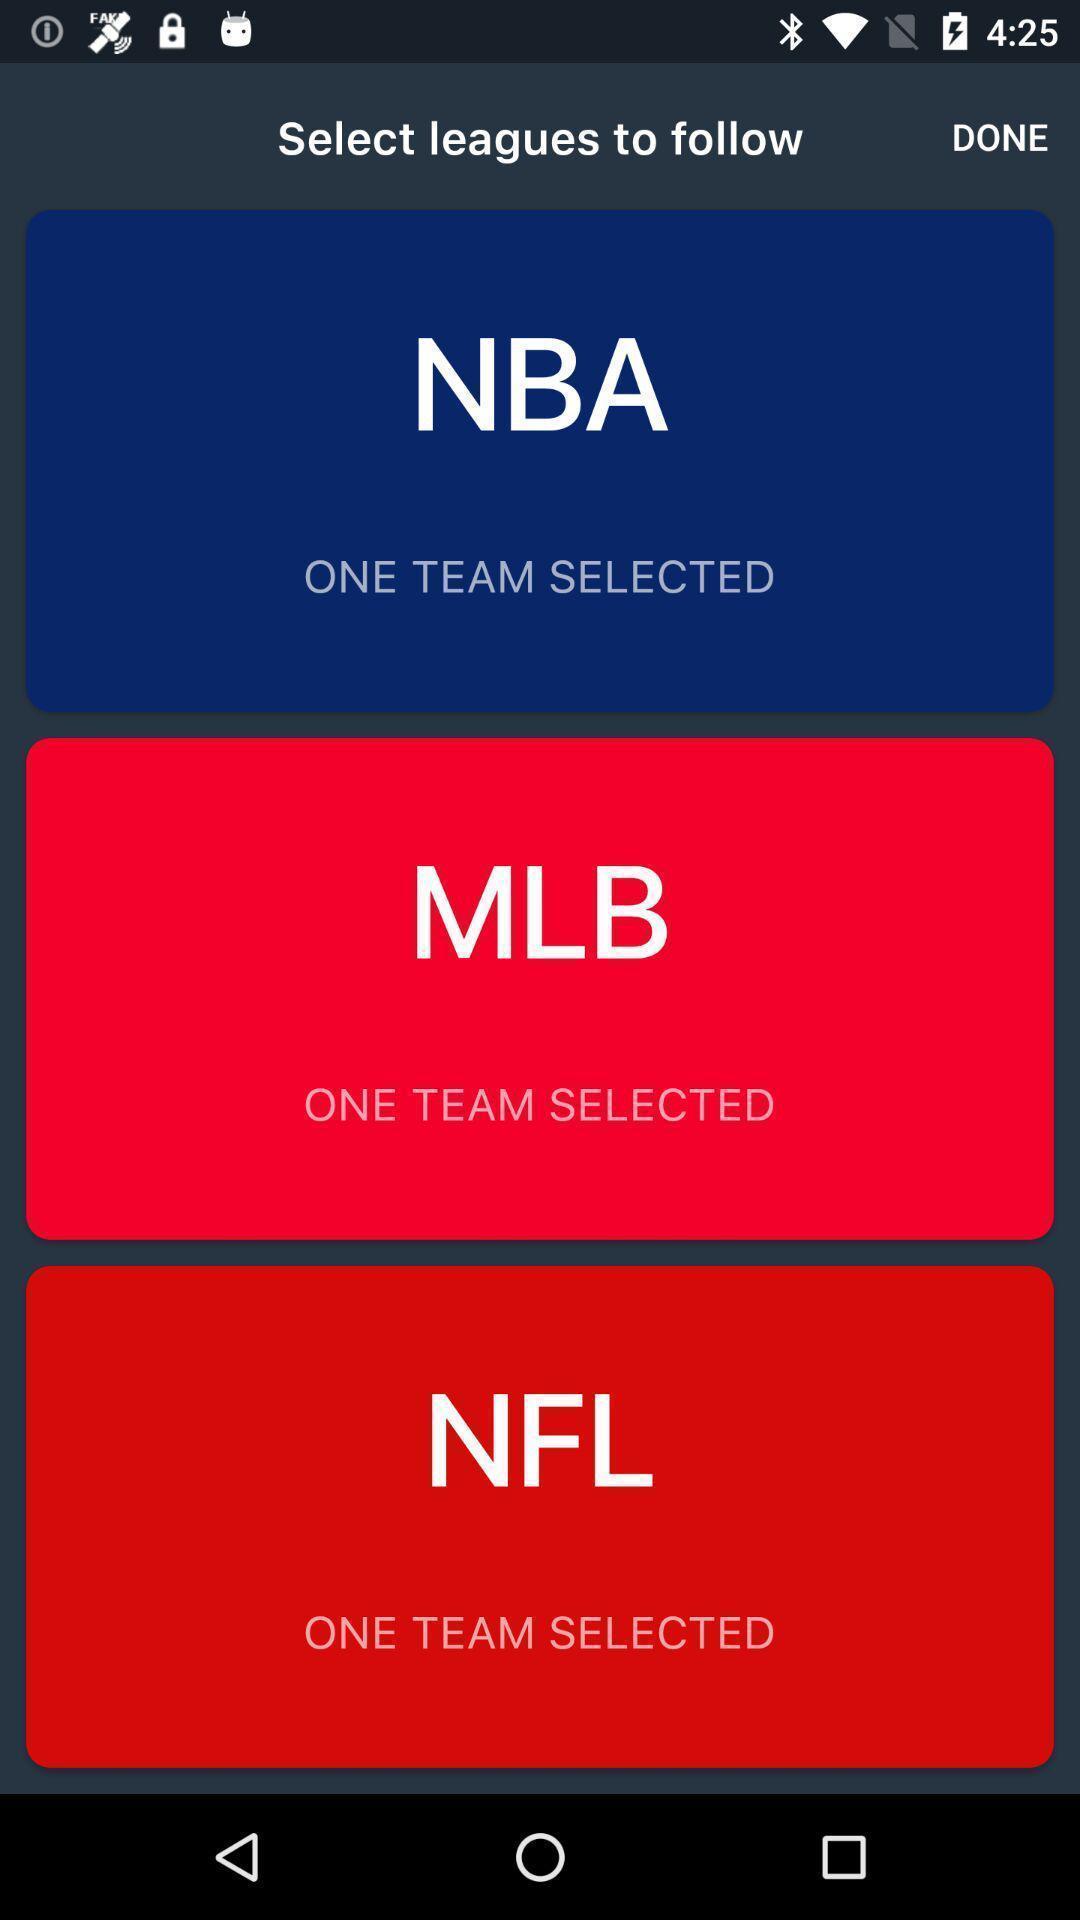Describe the visual elements of this screenshot. Selected team list showing in this page. 